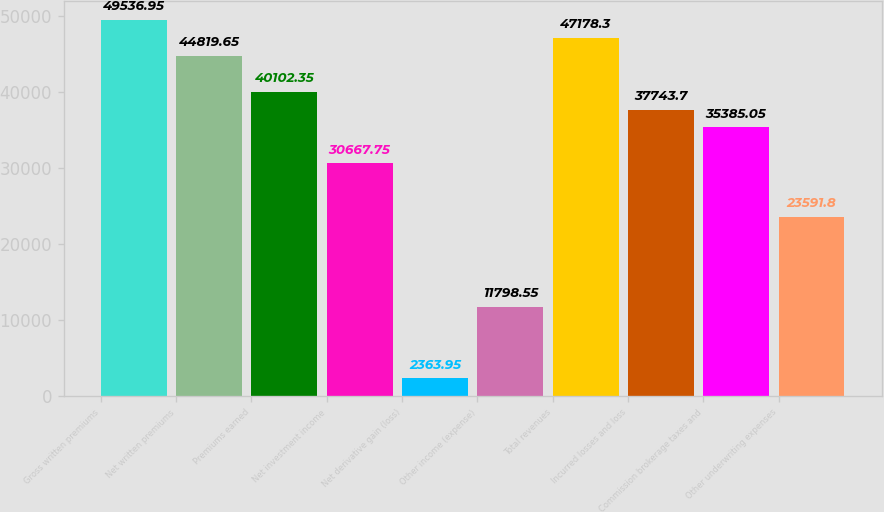<chart> <loc_0><loc_0><loc_500><loc_500><bar_chart><fcel>Gross written premiums<fcel>Net written premiums<fcel>Premiums earned<fcel>Net investment income<fcel>Net derivative gain (loss)<fcel>Other income (expense)<fcel>Total revenues<fcel>Incurred losses and loss<fcel>Commission brokerage taxes and<fcel>Other underwriting expenses<nl><fcel>49536.9<fcel>44819.7<fcel>40102.3<fcel>30667.8<fcel>2363.95<fcel>11798.5<fcel>47178.3<fcel>37743.7<fcel>35385.1<fcel>23591.8<nl></chart> 